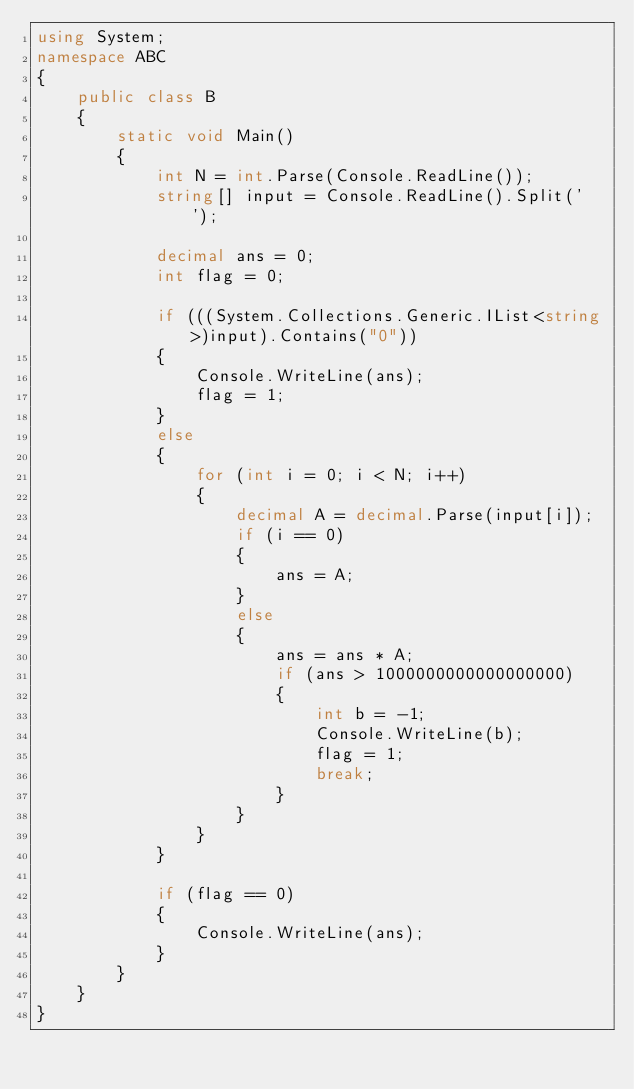Convert code to text. <code><loc_0><loc_0><loc_500><loc_500><_C#_>using System;
namespace ABC
{
    public class B
    {
        static void Main()
        {
            int N = int.Parse(Console.ReadLine());
            string[] input = Console.ReadLine().Split(' ');

            decimal ans = 0;
            int flag = 0;

            if (((System.Collections.Generic.IList<string>)input).Contains("0"))
            {
                Console.WriteLine(ans);
                flag = 1;
            }
            else
            {
                for (int i = 0; i < N; i++)
                {
                    decimal A = decimal.Parse(input[i]);
                    if (i == 0)
                    {
                        ans = A;
                    }
                    else
                    {
                        ans = ans * A;
                        if (ans > 1000000000000000000)
                        {
                            int b = -1;
                            Console.WriteLine(b);
                            flag = 1;
                            break;
                        }
                    }
                }
            }

            if (flag == 0)
            {
                Console.WriteLine(ans);
            }
        }
    }
}
</code> 